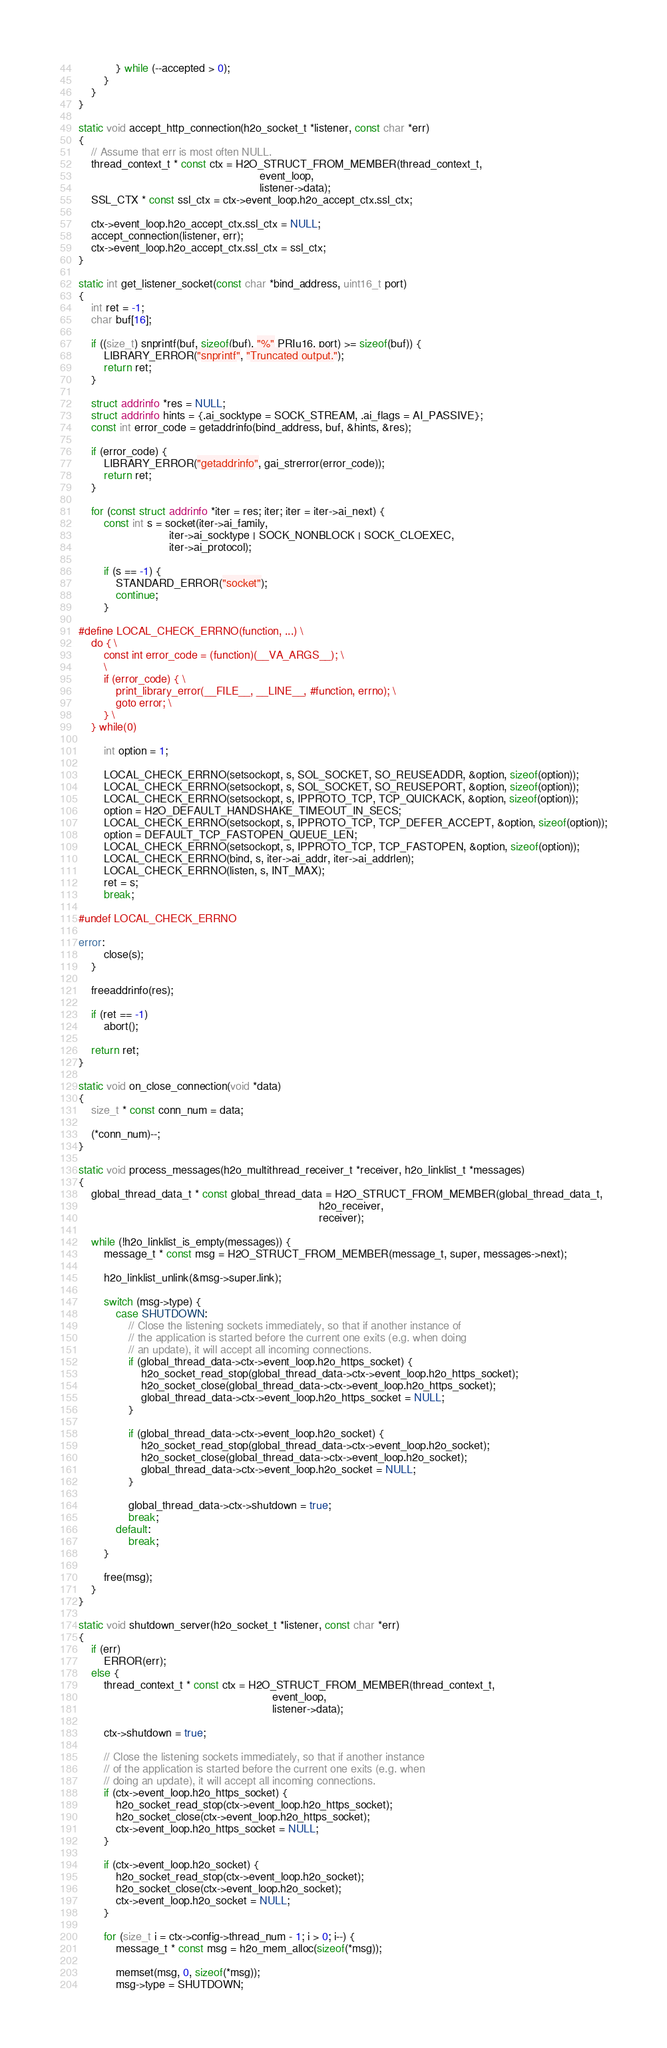<code> <loc_0><loc_0><loc_500><loc_500><_C_>			} while (--accepted > 0);
		}
	}
}

static void accept_http_connection(h2o_socket_t *listener, const char *err)
{
	// Assume that err is most often NULL.
	thread_context_t * const ctx = H2O_STRUCT_FROM_MEMBER(thread_context_t,
	                                                      event_loop,
	                                                      listener->data);
	SSL_CTX * const ssl_ctx = ctx->event_loop.h2o_accept_ctx.ssl_ctx;

	ctx->event_loop.h2o_accept_ctx.ssl_ctx = NULL;
	accept_connection(listener, err);
	ctx->event_loop.h2o_accept_ctx.ssl_ctx = ssl_ctx;
}

static int get_listener_socket(const char *bind_address, uint16_t port)
{
	int ret = -1;
	char buf[16];

	if ((size_t) snprintf(buf, sizeof(buf), "%" PRIu16, port) >= sizeof(buf)) {
		LIBRARY_ERROR("snprintf", "Truncated output.");
		return ret;
	}

	struct addrinfo *res = NULL;
	struct addrinfo hints = {.ai_socktype = SOCK_STREAM, .ai_flags = AI_PASSIVE};
	const int error_code = getaddrinfo(bind_address, buf, &hints, &res);

	if (error_code) {
		LIBRARY_ERROR("getaddrinfo", gai_strerror(error_code));
		return ret;
	}

	for (const struct addrinfo *iter = res; iter; iter = iter->ai_next) {
		const int s = socket(iter->ai_family,
		                     iter->ai_socktype | SOCK_NONBLOCK | SOCK_CLOEXEC,
		                     iter->ai_protocol);

		if (s == -1) {
			STANDARD_ERROR("socket");
			continue;
		}

#define LOCAL_CHECK_ERRNO(function, ...) \
	do { \
		const int error_code = (function)(__VA_ARGS__); \
		\
		if (error_code) { \
			print_library_error(__FILE__, __LINE__, #function, errno); \
			goto error; \
		} \
	} while(0)

		int option = 1;

		LOCAL_CHECK_ERRNO(setsockopt, s, SOL_SOCKET, SO_REUSEADDR, &option, sizeof(option));
		LOCAL_CHECK_ERRNO(setsockopt, s, SOL_SOCKET, SO_REUSEPORT, &option, sizeof(option));
		LOCAL_CHECK_ERRNO(setsockopt, s, IPPROTO_TCP, TCP_QUICKACK, &option, sizeof(option));
		option = H2O_DEFAULT_HANDSHAKE_TIMEOUT_IN_SECS;
		LOCAL_CHECK_ERRNO(setsockopt, s, IPPROTO_TCP, TCP_DEFER_ACCEPT, &option, sizeof(option));
		option = DEFAULT_TCP_FASTOPEN_QUEUE_LEN;
		LOCAL_CHECK_ERRNO(setsockopt, s, IPPROTO_TCP, TCP_FASTOPEN, &option, sizeof(option));
		LOCAL_CHECK_ERRNO(bind, s, iter->ai_addr, iter->ai_addrlen);
		LOCAL_CHECK_ERRNO(listen, s, INT_MAX);
		ret = s;
		break;

#undef LOCAL_CHECK_ERRNO

error:
		close(s);
	}

	freeaddrinfo(res);

	if (ret == -1)
		abort();

	return ret;
}

static void on_close_connection(void *data)
{
	size_t * const conn_num = data;

	(*conn_num)--;
}

static void process_messages(h2o_multithread_receiver_t *receiver, h2o_linklist_t *messages)
{
	global_thread_data_t * const global_thread_data = H2O_STRUCT_FROM_MEMBER(global_thread_data_t,
	                                                                         h2o_receiver,
	                                                                         receiver);

	while (!h2o_linklist_is_empty(messages)) {
		message_t * const msg = H2O_STRUCT_FROM_MEMBER(message_t, super, messages->next);

		h2o_linklist_unlink(&msg->super.link);

		switch (msg->type) {
			case SHUTDOWN:
				// Close the listening sockets immediately, so that if another instance of
				// the application is started before the current one exits (e.g. when doing
				// an update), it will accept all incoming connections.
				if (global_thread_data->ctx->event_loop.h2o_https_socket) {
					h2o_socket_read_stop(global_thread_data->ctx->event_loop.h2o_https_socket);
					h2o_socket_close(global_thread_data->ctx->event_loop.h2o_https_socket);
					global_thread_data->ctx->event_loop.h2o_https_socket = NULL;
				}

				if (global_thread_data->ctx->event_loop.h2o_socket) {
					h2o_socket_read_stop(global_thread_data->ctx->event_loop.h2o_socket);
					h2o_socket_close(global_thread_data->ctx->event_loop.h2o_socket);
					global_thread_data->ctx->event_loop.h2o_socket = NULL;
				}

				global_thread_data->ctx->shutdown = true;
				break;
			default:
				break;
		}

		free(msg);
	}
}

static void shutdown_server(h2o_socket_t *listener, const char *err)
{
	if (err)
		ERROR(err);
	else {
		thread_context_t * const ctx = H2O_STRUCT_FROM_MEMBER(thread_context_t,
		                                                      event_loop,
		                                                      listener->data);

		ctx->shutdown = true;

		// Close the listening sockets immediately, so that if another instance
		// of the application is started before the current one exits (e.g. when
		// doing an update), it will accept all incoming connections.
		if (ctx->event_loop.h2o_https_socket) {
			h2o_socket_read_stop(ctx->event_loop.h2o_https_socket);
			h2o_socket_close(ctx->event_loop.h2o_https_socket);
			ctx->event_loop.h2o_https_socket = NULL;
		}

		if (ctx->event_loop.h2o_socket) {
			h2o_socket_read_stop(ctx->event_loop.h2o_socket);
			h2o_socket_close(ctx->event_loop.h2o_socket);
			ctx->event_loop.h2o_socket = NULL;
		}

		for (size_t i = ctx->config->thread_num - 1; i > 0; i--) {
			message_t * const msg = h2o_mem_alloc(sizeof(*msg));

			memset(msg, 0, sizeof(*msg));
			msg->type = SHUTDOWN;</code> 